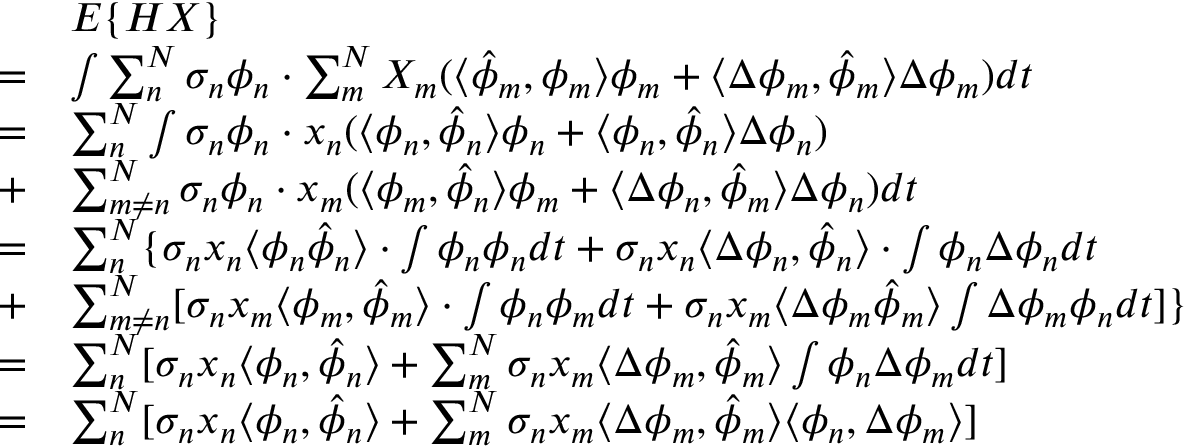Convert formula to latex. <formula><loc_0><loc_0><loc_500><loc_500>\begin{array} { r l } & { E \{ H X \} } \\ { = } & { \int \sum _ { n } ^ { N } \sigma _ { n } \phi _ { n } \cdot \sum _ { m } ^ { N } X _ { m } ( \langle \hat { \phi } _ { m } , \phi _ { m } \rangle \phi _ { m } + \langle \Delta \phi _ { m } , \hat { \phi } _ { m } \rangle \Delta \phi _ { m } ) d t } \\ { = } & { \sum _ { n } ^ { N } \int \sigma _ { n } \phi _ { n } \cdot x _ { n } ( \langle \phi _ { n } , \hat { \phi } _ { n } \rangle \phi _ { n } + \langle \phi _ { n } , \hat { \phi } _ { n } \rangle \Delta \phi _ { n } ) } \\ { + } & { \sum _ { m \neq n } ^ { N } \sigma _ { n } \phi _ { n } \cdot x _ { m } ( \langle \phi _ { m } , \hat { \phi } _ { n } \rangle \phi _ { m } + \langle \Delta \phi _ { n } , \hat { \phi } _ { m } \rangle \Delta \phi _ { n } ) d t } \\ { = } & { \sum _ { n } ^ { N } \{ \sigma _ { n } x _ { n } \langle \phi _ { n } \hat { \phi } _ { n } \rangle \cdot \int \phi _ { n } \phi _ { n } d t + \sigma _ { n } x _ { n } \langle \Delta \phi _ { n } , \hat { \phi } _ { n } \rangle \cdot \int \phi _ { n } \Delta \phi _ { n } d t } \\ { + } & { \sum _ { m \neq n } ^ { N } [ \sigma _ { n } x _ { m } \langle \phi _ { m } , \hat { \phi } _ { m } \rangle \cdot \int \phi _ { n } \phi _ { m } d t + \sigma _ { n } x _ { m } \langle \Delta \phi _ { m } \hat { \phi } _ { m } \rangle \int \Delta \phi _ { m } \phi _ { n } d t ] \} } \\ { = } & { \sum _ { n } ^ { N } [ \sigma _ { n } x _ { n } \langle \phi _ { n } , \hat { \phi } _ { n } \rangle + \sum _ { m } ^ { N } \sigma _ { n } x _ { m } \langle \Delta \phi _ { m } , \hat { \phi } _ { m } \rangle \int \phi _ { n } \Delta \phi _ { m } d t ] } \\ { = } & { \sum _ { n } ^ { N } [ \sigma _ { n } x _ { n } \langle \phi _ { n } , \hat { \phi } _ { n } \rangle + \sum _ { m } ^ { N } \sigma _ { n } x _ { m } \langle \Delta \phi _ { m } , \hat { \phi } _ { m } \rangle \langle \phi _ { n } , \Delta \phi _ { m } \rangle ] } \end{array}</formula> 